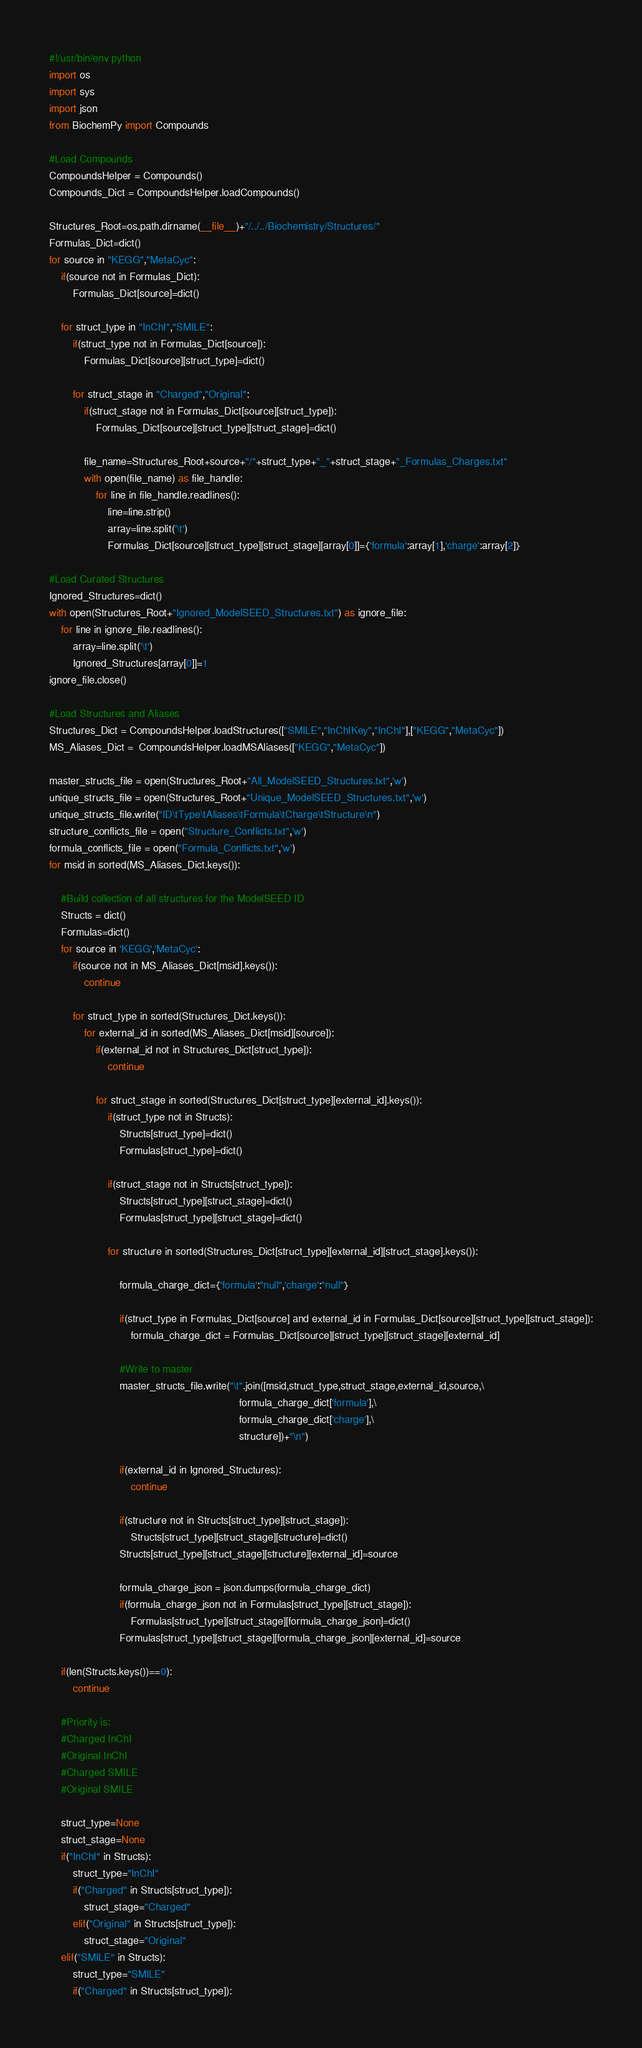Convert code to text. <code><loc_0><loc_0><loc_500><loc_500><_Python_>#!/usr/bin/env python
import os
import sys
import json
from BiochemPy import Compounds

#Load Compounds
CompoundsHelper = Compounds()
Compounds_Dict = CompoundsHelper.loadCompounds()

Structures_Root=os.path.dirname(__file__)+"/../../Biochemistry/Structures/"
Formulas_Dict=dict()
for source in "KEGG","MetaCyc":
    if(source not in Formulas_Dict):
        Formulas_Dict[source]=dict()

    for struct_type in "InChI","SMILE":
        if(struct_type not in Formulas_Dict[source]):
            Formulas_Dict[source][struct_type]=dict()

        for struct_stage in "Charged","Original":
            if(struct_stage not in Formulas_Dict[source][struct_type]):
                Formulas_Dict[source][struct_type][struct_stage]=dict()

            file_name=Structures_Root+source+"/"+struct_type+"_"+struct_stage+"_Formulas_Charges.txt"
            with open(file_name) as file_handle:
                for line in file_handle.readlines():
                    line=line.strip()
                    array=line.split('\t')
                    Formulas_Dict[source][struct_type][struct_stage][array[0]]={'formula':array[1],'charge':array[2]}

#Load Curated Structures
Ignored_Structures=dict()
with open(Structures_Root+"Ignored_ModelSEED_Structures.txt") as ignore_file:
    for line in ignore_file.readlines():
        array=line.split('\t')
        Ignored_Structures[array[0]]=1
ignore_file.close()

#Load Structures and Aliases
Structures_Dict = CompoundsHelper.loadStructures(["SMILE","InChIKey","InChI"],["KEGG","MetaCyc"])
MS_Aliases_Dict =  CompoundsHelper.loadMSAliases(["KEGG","MetaCyc"])

master_structs_file = open(Structures_Root+"All_ModelSEED_Structures.txt",'w')
unique_structs_file = open(Structures_Root+"Unique_ModelSEED_Structures.txt",'w')
unique_structs_file.write("ID\tType\tAliases\tFormula\tCharge\tStructure\n")
structure_conflicts_file = open("Structure_Conflicts.txt",'w')
formula_conflicts_file = open("Formula_Conflicts.txt",'w')
for msid in sorted(MS_Aliases_Dict.keys()):

    #Build collection of all structures for the ModelSEED ID
    Structs = dict()
    Formulas=dict()
    for source in 'KEGG','MetaCyc':
        if(source not in MS_Aliases_Dict[msid].keys()):
            continue

        for struct_type in sorted(Structures_Dict.keys()):
            for external_id in sorted(MS_Aliases_Dict[msid][source]):
                if(external_id not in Structures_Dict[struct_type]):
                    continue

                for struct_stage in sorted(Structures_Dict[struct_type][external_id].keys()):
                    if(struct_type not in Structs):
                        Structs[struct_type]=dict()
                        Formulas[struct_type]=dict()

                    if(struct_stage not in Structs[struct_type]):
                        Structs[struct_type][struct_stage]=dict()
                        Formulas[struct_type][struct_stage]=dict()

                    for structure in sorted(Structures_Dict[struct_type][external_id][struct_stage].keys()):

                        formula_charge_dict={'formula':"null",'charge':"null"}

                        if(struct_type in Formulas_Dict[source] and external_id in Formulas_Dict[source][struct_type][struct_stage]):
                            formula_charge_dict = Formulas_Dict[source][struct_type][struct_stage][external_id]

                        #Write to master
                        master_structs_file.write("\t".join([msid,struct_type,struct_stage,external_id,source,\
                                                                 formula_charge_dict['formula'],\
                                                                 formula_charge_dict['charge'],\
                                                                 structure])+"\n")

                        if(external_id in Ignored_Structures):
                            continue

                        if(structure not in Structs[struct_type][struct_stage]):
                            Structs[struct_type][struct_stage][structure]=dict()
                        Structs[struct_type][struct_stage][structure][external_id]=source

                        formula_charge_json = json.dumps(formula_charge_dict)
                        if(formula_charge_json not in Formulas[struct_type][struct_stage]):
                            Formulas[struct_type][struct_stage][formula_charge_json]=dict()
                        Formulas[struct_type][struct_stage][formula_charge_json][external_id]=source

    if(len(Structs.keys())==0):
        continue

    #Priority is:
    #Charged InChI
    #Original InChI
    #Charged SMILE
    #Original SMILE

    struct_type=None
    struct_stage=None
    if("InChI" in Structs):
        struct_type="InChI"
        if("Charged" in Structs[struct_type]):
            struct_stage="Charged"
        elif("Original" in Structs[struct_type]):
            struct_stage="Original"
    elif("SMILE" in Structs):
        struct_type="SMILE"
        if("Charged" in Structs[struct_type]):</code> 